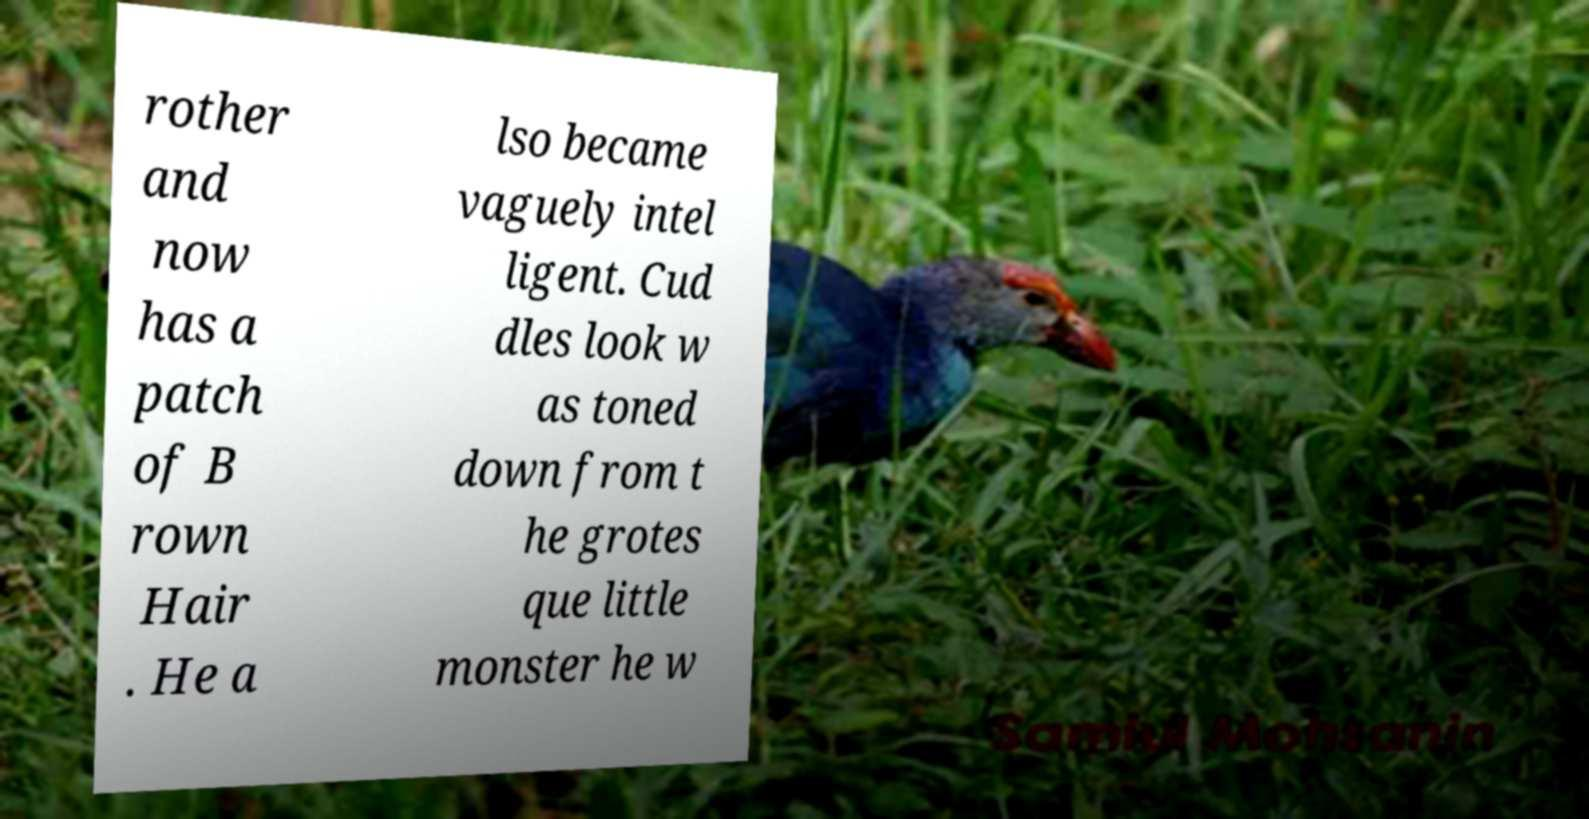Please identify and transcribe the text found in this image. rother and now has a patch of B rown Hair . He a lso became vaguely intel ligent. Cud dles look w as toned down from t he grotes que little monster he w 